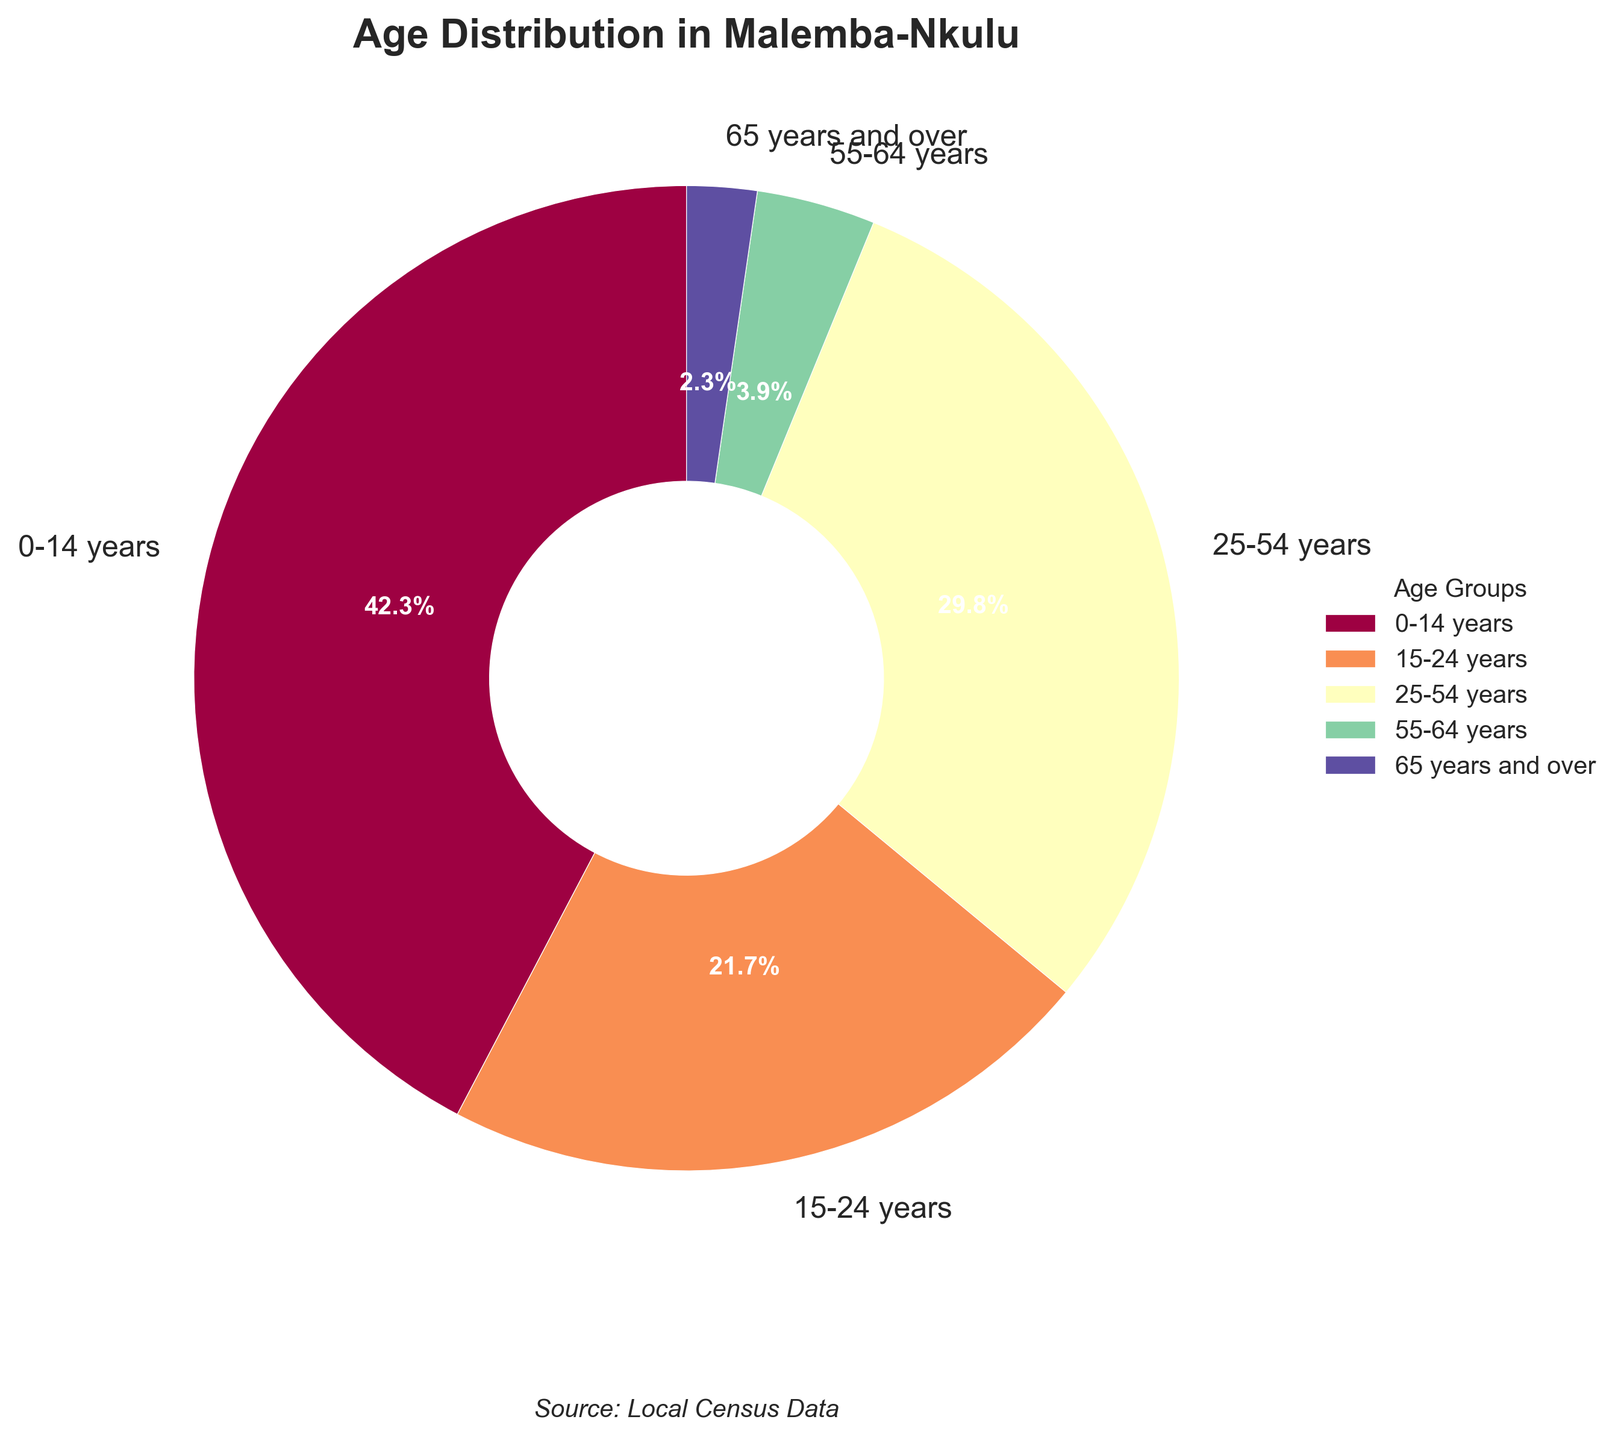What percentage of the population in Malemba-Nkulu is under 25 years old? To find the percentage, sum the percentages of the 0-14 years and 15-24 years groups (42.3% + 21.7%). This equals 64%.
Answer: 64% Which age group has the largest population? To determine the largest group, compare percentages of all age groups. The 0-14 years group has the highest percentage at 42.3%.
Answer: 0-14 years How much larger is the population percentage of youths (0-14 years) compared to the elderly (65 years and over)? Subtract the percentage of the 65 years and over group from the 0-14 years group (42.3% - 2.3%). This equals 40%.
Answer: 40% What are the combined percentages of adults aged 25-54 and 55-64 years? Add the percentages of the 25-54 years and 55-64 years groups (29.8% + 3.9%). This totals to 33.7%.
Answer: 33.7% How many age groups have a population percentage above 20%? Compare each age group's percentage to 20%. The groups 0-14 years (42.3%) and 15-24 years (21.7%) are above 20%.
Answer: 2 Which age group has the smallest population and what percentage is it? Identify the age group with the lowest percentage, which is 65 years and over at 2.3%.
Answer: 65 years and over, 2.3% What fraction of the population is comprised of elderly adults (55 years and over)? Add the percentages of the 55-64 years and 65 years and over groups (3.9% + 2.3%). This is 6.2%.
Answer: 6.2% What is the difference in population percentage between the 15-24 years group and the 25-54 years group? Subtract the percentage of the 15-24 years group from the 25-54 years group (29.8% - 21.7%). This equals 8.1%.
Answer: 8.1% Is there a significant difference between the population percentages of the 0-14 years group and the 15-24 years group? Compare the percentages of 0-14 years and 15-24 years groups (42.3% and 21.7% respectively). The difference is 42.3% - 21.7% = 20.6%, which is significant.
Answer: Yes, 20.6% 